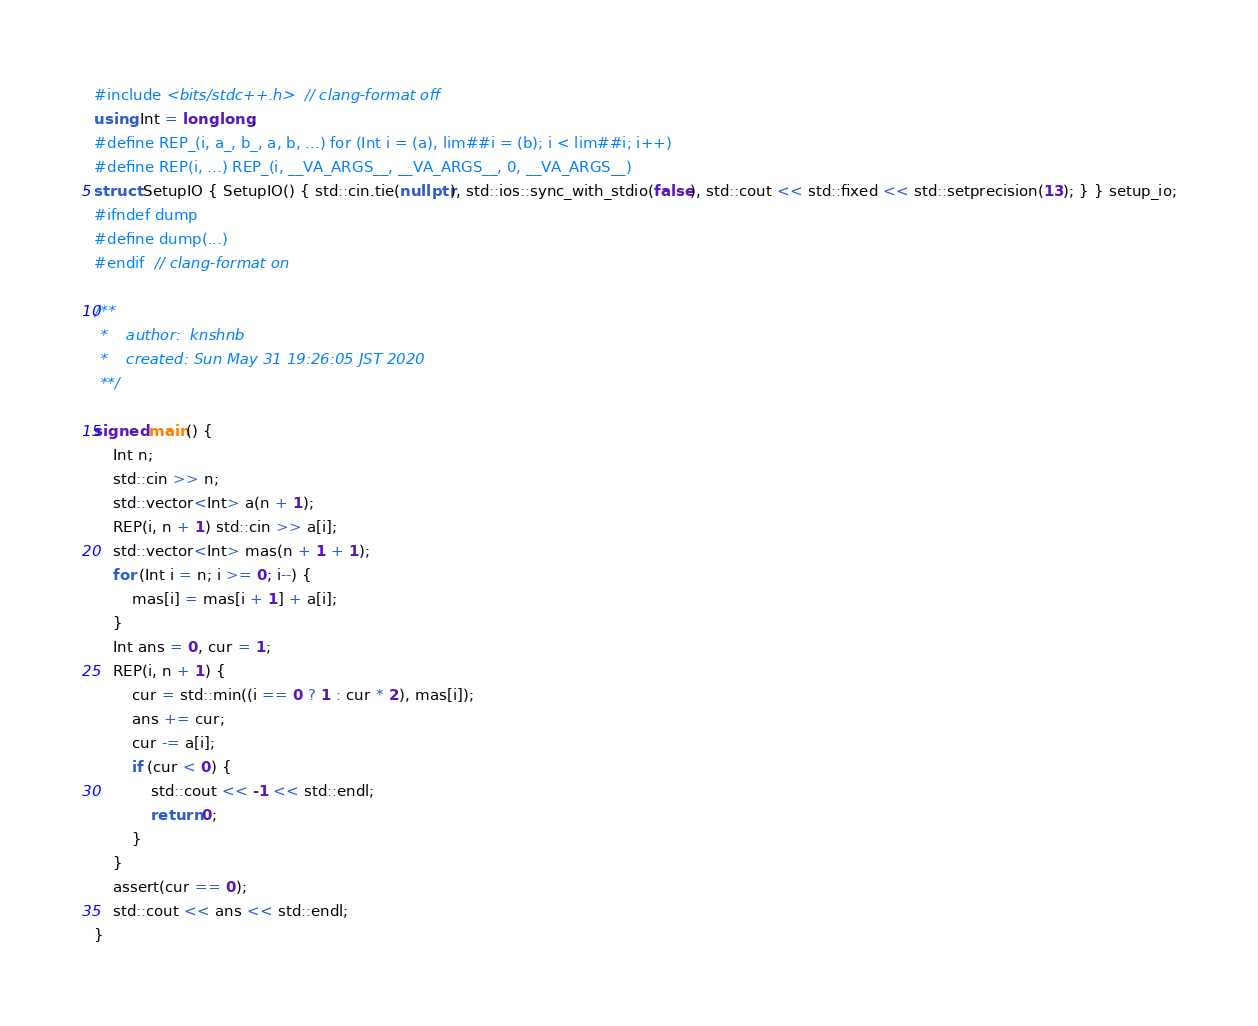<code> <loc_0><loc_0><loc_500><loc_500><_C++_>#include <bits/stdc++.h>  // clang-format off
using Int = long long;
#define REP_(i, a_, b_, a, b, ...) for (Int i = (a), lim##i = (b); i < lim##i; i++)
#define REP(i, ...) REP_(i, __VA_ARGS__, __VA_ARGS__, 0, __VA_ARGS__)
struct SetupIO { SetupIO() { std::cin.tie(nullptr), std::ios::sync_with_stdio(false), std::cout << std::fixed << std::setprecision(13); } } setup_io;
#ifndef dump
#define dump(...)
#endif  // clang-format on

/**
 *    author:  knshnb
 *    created: Sun May 31 19:26:05 JST 2020
 **/

signed main() {
    Int n;
    std::cin >> n;
    std::vector<Int> a(n + 1);
    REP(i, n + 1) std::cin >> a[i];
    std::vector<Int> mas(n + 1 + 1);
    for (Int i = n; i >= 0; i--) {
        mas[i] = mas[i + 1] + a[i];
    }
    Int ans = 0, cur = 1;
    REP(i, n + 1) {
        cur = std::min((i == 0 ? 1 : cur * 2), mas[i]);
        ans += cur;
        cur -= a[i];
        if (cur < 0) {
            std::cout << -1 << std::endl;
            return 0;
        }
    }
    assert(cur == 0);
    std::cout << ans << std::endl;
}
</code> 